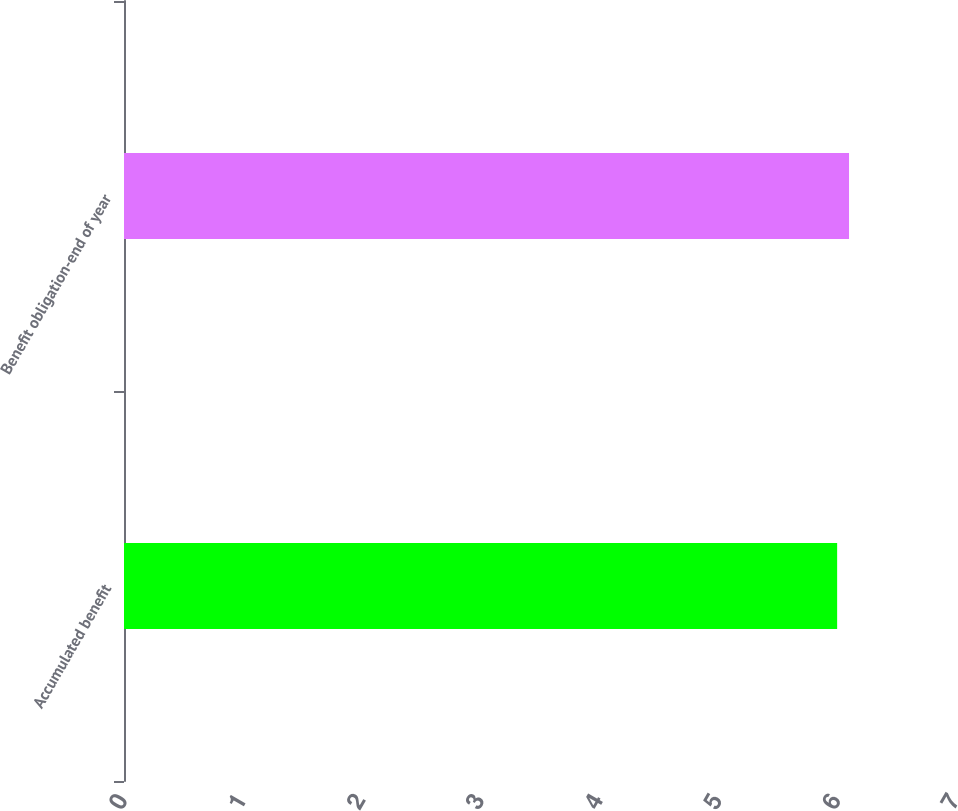<chart> <loc_0><loc_0><loc_500><loc_500><bar_chart><fcel>Accumulated benefit<fcel>Benefit obligation-end of year<nl><fcel>6<fcel>6.1<nl></chart> 